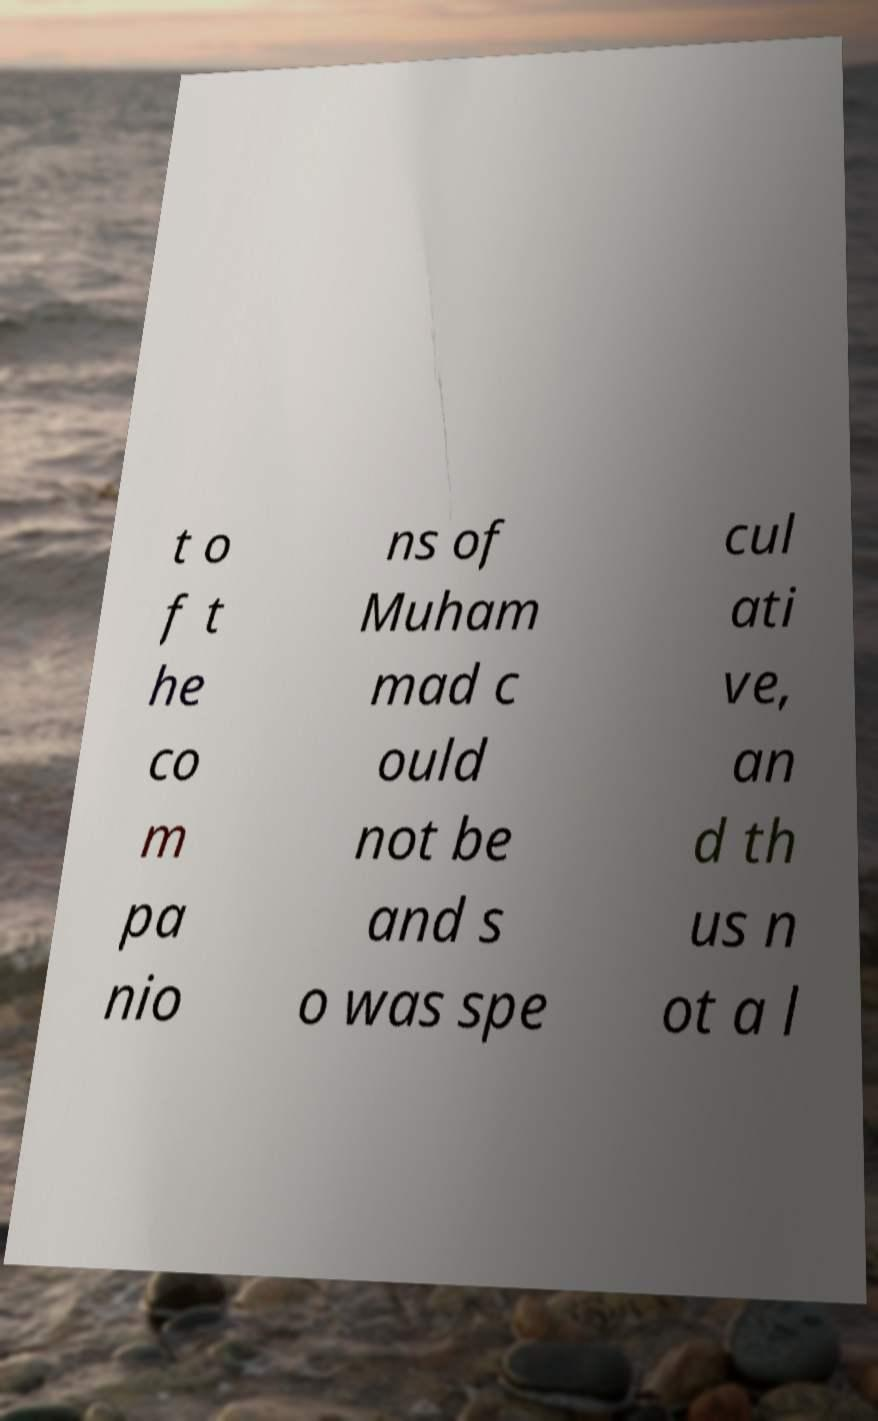Please identify and transcribe the text found in this image. t o f t he co m pa nio ns of Muham mad c ould not be and s o was spe cul ati ve, an d th us n ot a l 